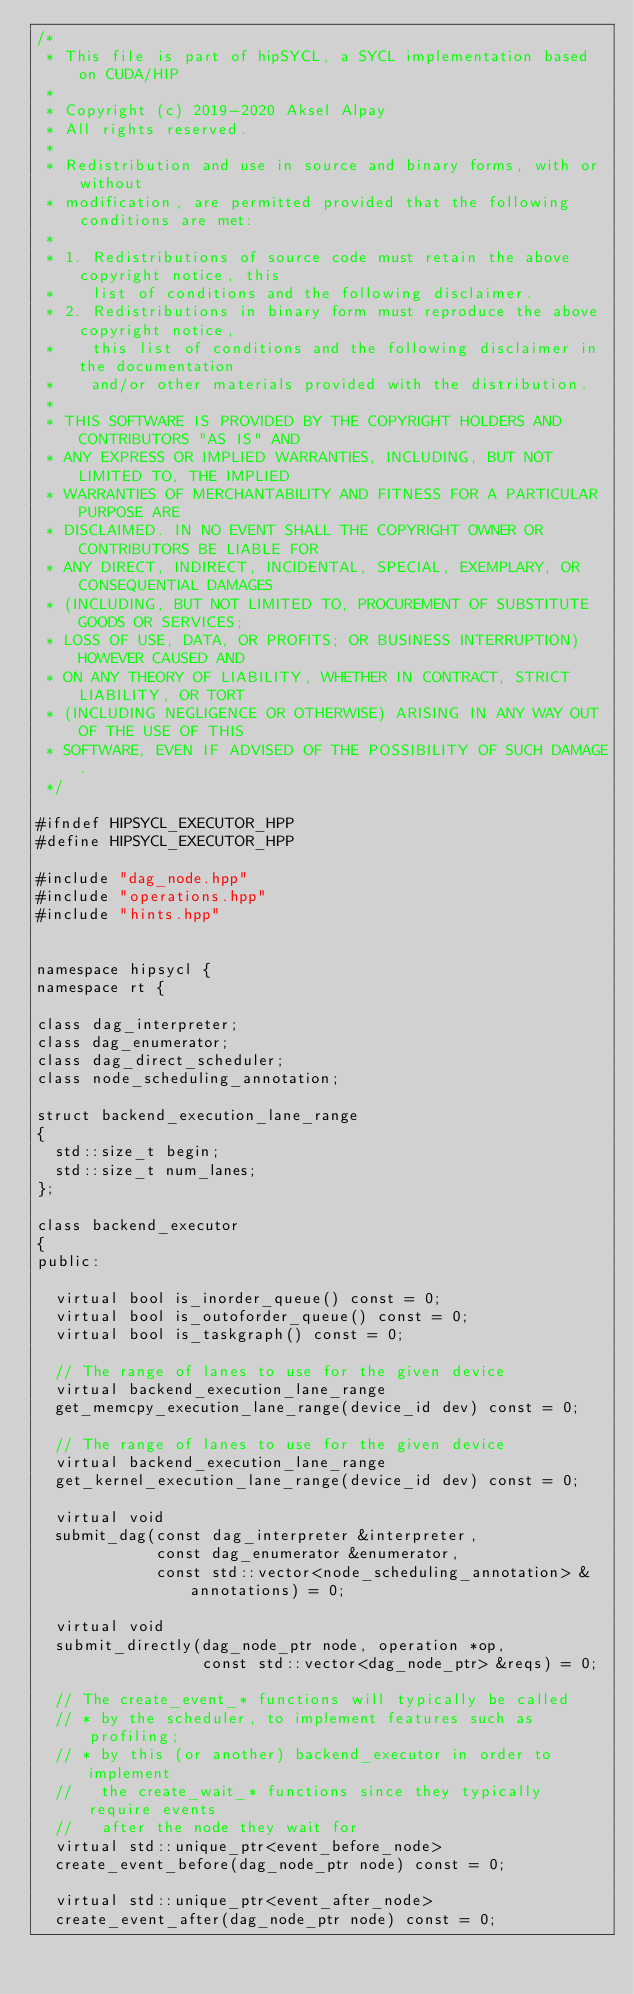<code> <loc_0><loc_0><loc_500><loc_500><_C++_>/*
 * This file is part of hipSYCL, a SYCL implementation based on CUDA/HIP
 *
 * Copyright (c) 2019-2020 Aksel Alpay
 * All rights reserved.
 *
 * Redistribution and use in source and binary forms, with or without
 * modification, are permitted provided that the following conditions are met:
 *
 * 1. Redistributions of source code must retain the above copyright notice, this
 *    list of conditions and the following disclaimer.
 * 2. Redistributions in binary form must reproduce the above copyright notice,
 *    this list of conditions and the following disclaimer in the documentation
 *    and/or other materials provided with the distribution.
 *
 * THIS SOFTWARE IS PROVIDED BY THE COPYRIGHT HOLDERS AND CONTRIBUTORS "AS IS" AND
 * ANY EXPRESS OR IMPLIED WARRANTIES, INCLUDING, BUT NOT LIMITED TO, THE IMPLIED
 * WARRANTIES OF MERCHANTABILITY AND FITNESS FOR A PARTICULAR PURPOSE ARE
 * DISCLAIMED. IN NO EVENT SHALL THE COPYRIGHT OWNER OR CONTRIBUTORS BE LIABLE FOR
 * ANY DIRECT, INDIRECT, INCIDENTAL, SPECIAL, EXEMPLARY, OR CONSEQUENTIAL DAMAGES
 * (INCLUDING, BUT NOT LIMITED TO, PROCUREMENT OF SUBSTITUTE GOODS OR SERVICES;
 * LOSS OF USE, DATA, OR PROFITS; OR BUSINESS INTERRUPTION) HOWEVER CAUSED AND
 * ON ANY THEORY OF LIABILITY, WHETHER IN CONTRACT, STRICT LIABILITY, OR TORT
 * (INCLUDING NEGLIGENCE OR OTHERWISE) ARISING IN ANY WAY OUT OF THE USE OF THIS
 * SOFTWARE, EVEN IF ADVISED OF THE POSSIBILITY OF SUCH DAMAGE.
 */

#ifndef HIPSYCL_EXECUTOR_HPP
#define HIPSYCL_EXECUTOR_HPP

#include "dag_node.hpp"
#include "operations.hpp"
#include "hints.hpp"


namespace hipsycl {
namespace rt {

class dag_interpreter;
class dag_enumerator;
class dag_direct_scheduler;
class node_scheduling_annotation;

struct backend_execution_lane_range
{
  std::size_t begin;
  std::size_t num_lanes;
};

class backend_executor
{
public:

  virtual bool is_inorder_queue() const = 0;
  virtual bool is_outoforder_queue() const = 0;
  virtual bool is_taskgraph() const = 0;

  // The range of lanes to use for the given device
  virtual backend_execution_lane_range
  get_memcpy_execution_lane_range(device_id dev) const = 0;

  // The range of lanes to use for the given device
  virtual backend_execution_lane_range
  get_kernel_execution_lane_range(device_id dev) const = 0;

  virtual void
  submit_dag(const dag_interpreter &interpreter,
             const dag_enumerator &enumerator,
             const std::vector<node_scheduling_annotation> &annotations) = 0;

  virtual void
  submit_directly(dag_node_ptr node, operation *op,
                  const std::vector<dag_node_ptr> &reqs) = 0;

  // The create_event_* functions will typically be called
  // * by the scheduler, to implement features such as profiling;
  // * by this (or another) backend_executor in order to implement
  //   the create_wait_* functions since they typically require events
  //   after the node they wait for
  virtual std::unique_ptr<event_before_node>
  create_event_before(dag_node_ptr node) const = 0;

  virtual std::unique_ptr<event_after_node>
  create_event_after(dag_node_ptr node) const = 0;
</code> 